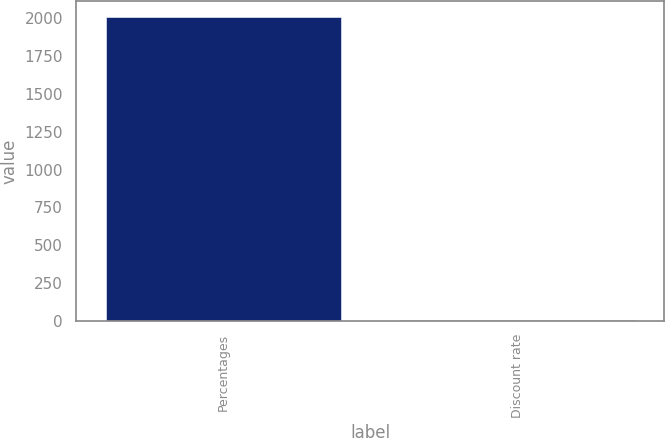<chart> <loc_0><loc_0><loc_500><loc_500><bar_chart><fcel>Percentages<fcel>Discount rate<nl><fcel>2012<fcel>4.54<nl></chart> 